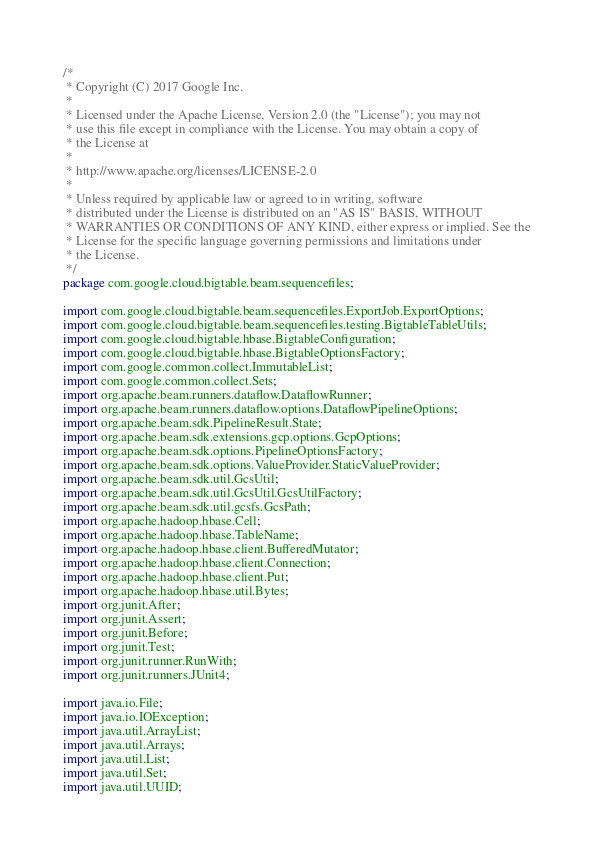Convert code to text. <code><loc_0><loc_0><loc_500><loc_500><_Java_>/*
 * Copyright (C) 2017 Google Inc.
 *
 * Licensed under the Apache License, Version 2.0 (the "License"); you may not
 * use this file except in compliance with the License. You may obtain a copy of
 * the License at
 *
 * http://www.apache.org/licenses/LICENSE-2.0
 *
 * Unless required by applicable law or agreed to in writing, software
 * distributed under the License is distributed on an "AS IS" BASIS, WITHOUT
 * WARRANTIES OR CONDITIONS OF ANY KIND, either express or implied. See the
 * License for the specific language governing permissions and limitations under
 * the License.
 */
package com.google.cloud.bigtable.beam.sequencefiles;

import com.google.cloud.bigtable.beam.sequencefiles.ExportJob.ExportOptions;
import com.google.cloud.bigtable.beam.sequencefiles.testing.BigtableTableUtils;
import com.google.cloud.bigtable.hbase.BigtableConfiguration;
import com.google.cloud.bigtable.hbase.BigtableOptionsFactory;
import com.google.common.collect.ImmutableList;
import com.google.common.collect.Sets;
import org.apache.beam.runners.dataflow.DataflowRunner;
import org.apache.beam.runners.dataflow.options.DataflowPipelineOptions;
import org.apache.beam.sdk.PipelineResult.State;
import org.apache.beam.sdk.extensions.gcp.options.GcpOptions;
import org.apache.beam.sdk.options.PipelineOptionsFactory;
import org.apache.beam.sdk.options.ValueProvider.StaticValueProvider;
import org.apache.beam.sdk.util.GcsUtil;
import org.apache.beam.sdk.util.GcsUtil.GcsUtilFactory;
import org.apache.beam.sdk.util.gcsfs.GcsPath;
import org.apache.hadoop.hbase.Cell;
import org.apache.hadoop.hbase.TableName;
import org.apache.hadoop.hbase.client.BufferedMutator;
import org.apache.hadoop.hbase.client.Connection;
import org.apache.hadoop.hbase.client.Put;
import org.apache.hadoop.hbase.util.Bytes;
import org.junit.After;
import org.junit.Assert;
import org.junit.Before;
import org.junit.Test;
import org.junit.runner.RunWith;
import org.junit.runners.JUnit4;

import java.io.File;
import java.io.IOException;
import java.util.ArrayList;
import java.util.Arrays;
import java.util.List;
import java.util.Set;
import java.util.UUID;
</code> 